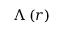Convert formula to latex. <formula><loc_0><loc_0><loc_500><loc_500>\Lambda \left ( r \right )</formula> 